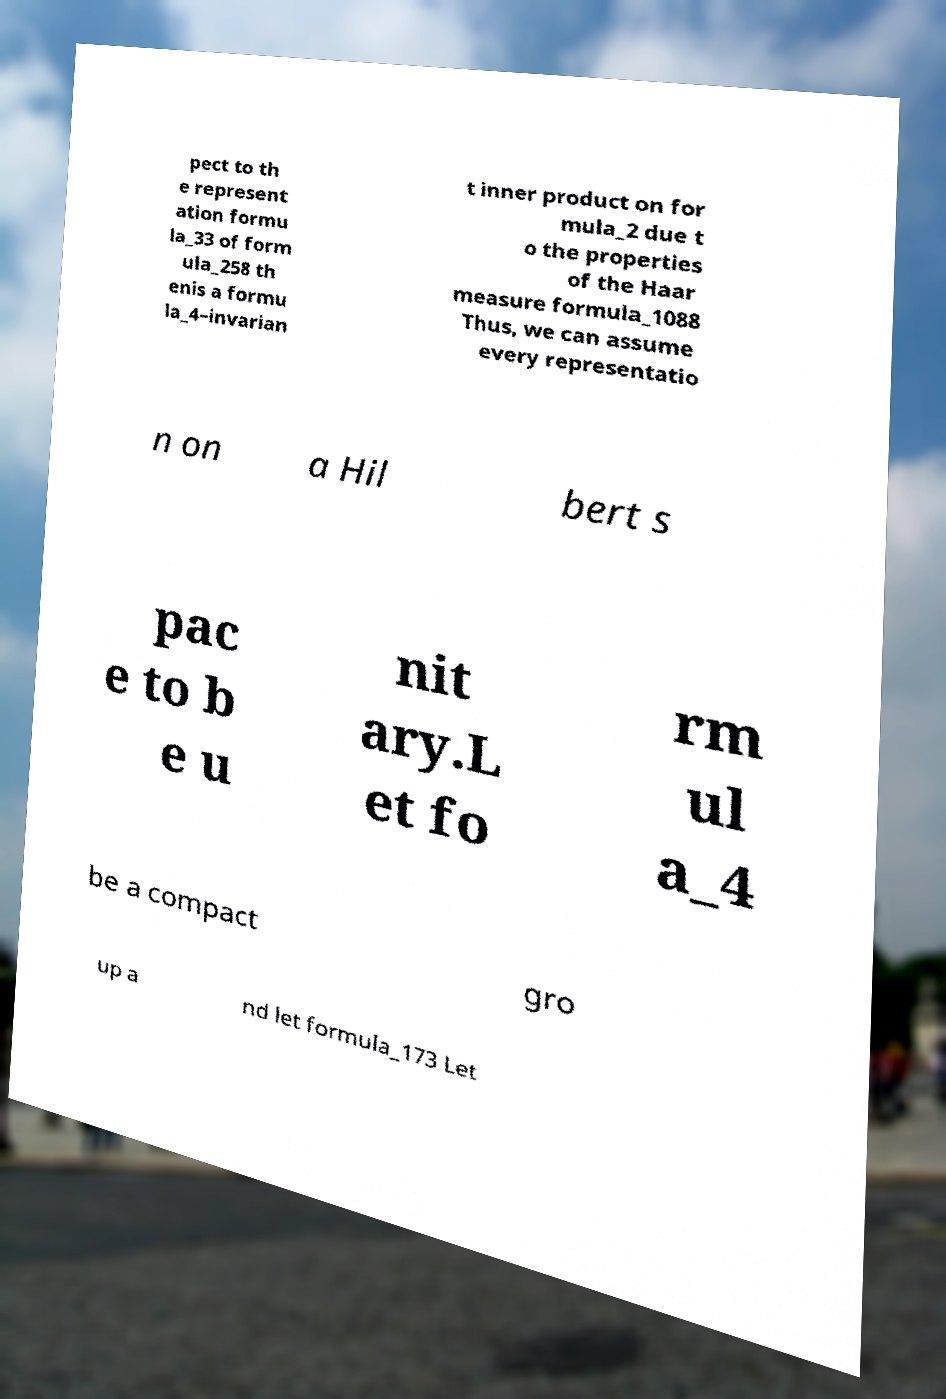What messages or text are displayed in this image? I need them in a readable, typed format. pect to th e represent ation formu la_33 of form ula_258 th enis a formu la_4–invarian t inner product on for mula_2 due t o the properties of the Haar measure formula_1088 Thus, we can assume every representatio n on a Hil bert s pac e to b e u nit ary.L et fo rm ul a_4 be a compact gro up a nd let formula_173 Let 